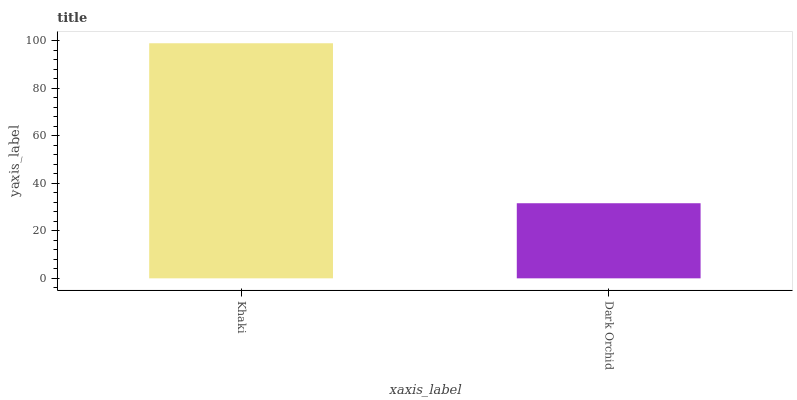Is Dark Orchid the minimum?
Answer yes or no. Yes. Is Khaki the maximum?
Answer yes or no. Yes. Is Dark Orchid the maximum?
Answer yes or no. No. Is Khaki greater than Dark Orchid?
Answer yes or no. Yes. Is Dark Orchid less than Khaki?
Answer yes or no. Yes. Is Dark Orchid greater than Khaki?
Answer yes or no. No. Is Khaki less than Dark Orchid?
Answer yes or no. No. Is Khaki the high median?
Answer yes or no. Yes. Is Dark Orchid the low median?
Answer yes or no. Yes. Is Dark Orchid the high median?
Answer yes or no. No. Is Khaki the low median?
Answer yes or no. No. 